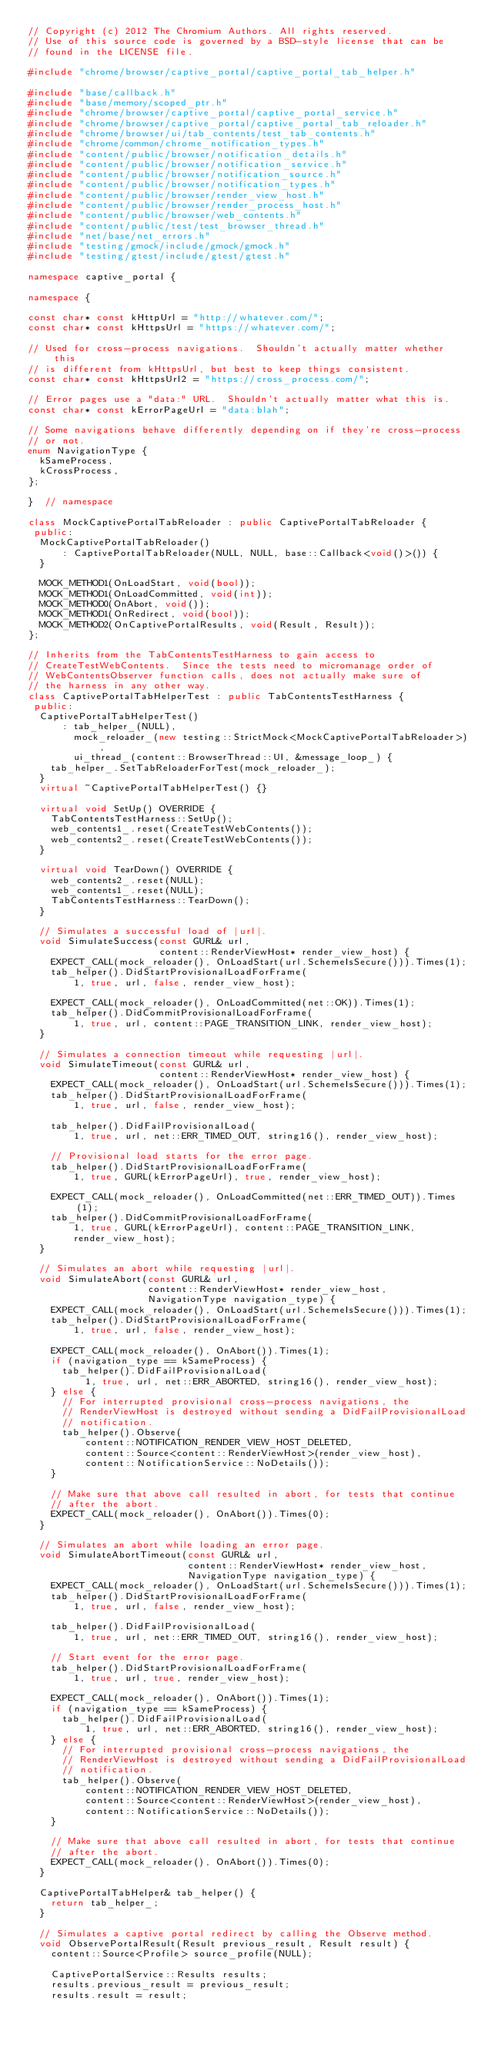<code> <loc_0><loc_0><loc_500><loc_500><_C++_>// Copyright (c) 2012 The Chromium Authors. All rights reserved.
// Use of this source code is governed by a BSD-style license that can be
// found in the LICENSE file.

#include "chrome/browser/captive_portal/captive_portal_tab_helper.h"

#include "base/callback.h"
#include "base/memory/scoped_ptr.h"
#include "chrome/browser/captive_portal/captive_portal_service.h"
#include "chrome/browser/captive_portal/captive_portal_tab_reloader.h"
#include "chrome/browser/ui/tab_contents/test_tab_contents.h"
#include "chrome/common/chrome_notification_types.h"
#include "content/public/browser/notification_details.h"
#include "content/public/browser/notification_service.h"
#include "content/public/browser/notification_source.h"
#include "content/public/browser/notification_types.h"
#include "content/public/browser/render_view_host.h"
#include "content/public/browser/render_process_host.h"
#include "content/public/browser/web_contents.h"
#include "content/public/test/test_browser_thread.h"
#include "net/base/net_errors.h"
#include "testing/gmock/include/gmock/gmock.h"
#include "testing/gtest/include/gtest/gtest.h"

namespace captive_portal {

namespace {

const char* const kHttpUrl = "http://whatever.com/";
const char* const kHttpsUrl = "https://whatever.com/";

// Used for cross-process navigations.  Shouldn't actually matter whether this
// is different from kHttpsUrl, but best to keep things consistent.
const char* const kHttpsUrl2 = "https://cross_process.com/";

// Error pages use a "data:" URL.  Shouldn't actually matter what this is.
const char* const kErrorPageUrl = "data:blah";

// Some navigations behave differently depending on if they're cross-process
// or not.
enum NavigationType {
  kSameProcess,
  kCrossProcess,
};

}  // namespace

class MockCaptivePortalTabReloader : public CaptivePortalTabReloader {
 public:
  MockCaptivePortalTabReloader()
      : CaptivePortalTabReloader(NULL, NULL, base::Callback<void()>()) {
  }

  MOCK_METHOD1(OnLoadStart, void(bool));
  MOCK_METHOD1(OnLoadCommitted, void(int));
  MOCK_METHOD0(OnAbort, void());
  MOCK_METHOD1(OnRedirect, void(bool));
  MOCK_METHOD2(OnCaptivePortalResults, void(Result, Result));
};

// Inherits from the TabContentsTestHarness to gain access to
// CreateTestWebContents.  Since the tests need to micromanage order of
// WebContentsObserver function calls, does not actually make sure of
// the harness in any other way.
class CaptivePortalTabHelperTest : public TabContentsTestHarness {
 public:
  CaptivePortalTabHelperTest()
      : tab_helper_(NULL),
        mock_reloader_(new testing::StrictMock<MockCaptivePortalTabReloader>),
        ui_thread_(content::BrowserThread::UI, &message_loop_) {
    tab_helper_.SetTabReloaderForTest(mock_reloader_);
  }
  virtual ~CaptivePortalTabHelperTest() {}

  virtual void SetUp() OVERRIDE {
    TabContentsTestHarness::SetUp();
    web_contents1_.reset(CreateTestWebContents());
    web_contents2_.reset(CreateTestWebContents());
  }

  virtual void TearDown() OVERRIDE {
    web_contents2_.reset(NULL);
    web_contents1_.reset(NULL);
    TabContentsTestHarness::TearDown();
  }

  // Simulates a successful load of |url|.
  void SimulateSuccess(const GURL& url,
                       content::RenderViewHost* render_view_host) {
    EXPECT_CALL(mock_reloader(), OnLoadStart(url.SchemeIsSecure())).Times(1);
    tab_helper().DidStartProvisionalLoadForFrame(
        1, true, url, false, render_view_host);

    EXPECT_CALL(mock_reloader(), OnLoadCommitted(net::OK)).Times(1);
    tab_helper().DidCommitProvisionalLoadForFrame(
        1, true, url, content::PAGE_TRANSITION_LINK, render_view_host);
  }

  // Simulates a connection timeout while requesting |url|.
  void SimulateTimeout(const GURL& url,
                       content::RenderViewHost* render_view_host) {
    EXPECT_CALL(mock_reloader(), OnLoadStart(url.SchemeIsSecure())).Times(1);
    tab_helper().DidStartProvisionalLoadForFrame(
        1, true, url, false, render_view_host);

    tab_helper().DidFailProvisionalLoad(
        1, true, url, net::ERR_TIMED_OUT, string16(), render_view_host);

    // Provisional load starts for the error page.
    tab_helper().DidStartProvisionalLoadForFrame(
        1, true, GURL(kErrorPageUrl), true, render_view_host);

    EXPECT_CALL(mock_reloader(), OnLoadCommitted(net::ERR_TIMED_OUT)).Times(1);
    tab_helper().DidCommitProvisionalLoadForFrame(
        1, true, GURL(kErrorPageUrl), content::PAGE_TRANSITION_LINK,
        render_view_host);
  }

  // Simulates an abort while requesting |url|.
  void SimulateAbort(const GURL& url,
                     content::RenderViewHost* render_view_host,
                     NavigationType navigation_type) {
    EXPECT_CALL(mock_reloader(), OnLoadStart(url.SchemeIsSecure())).Times(1);
    tab_helper().DidStartProvisionalLoadForFrame(
        1, true, url, false, render_view_host);

    EXPECT_CALL(mock_reloader(), OnAbort()).Times(1);
    if (navigation_type == kSameProcess) {
      tab_helper().DidFailProvisionalLoad(
          1, true, url, net::ERR_ABORTED, string16(), render_view_host);
    } else {
      // For interrupted provisional cross-process navigations, the
      // RenderViewHost is destroyed without sending a DidFailProvisionalLoad
      // notification.
      tab_helper().Observe(
          content::NOTIFICATION_RENDER_VIEW_HOST_DELETED,
          content::Source<content::RenderViewHost>(render_view_host),
          content::NotificationService::NoDetails());
    }

    // Make sure that above call resulted in abort, for tests that continue
    // after the abort.
    EXPECT_CALL(mock_reloader(), OnAbort()).Times(0);
  }

  // Simulates an abort while loading an error page.
  void SimulateAbortTimeout(const GURL& url,
                            content::RenderViewHost* render_view_host,
                            NavigationType navigation_type) {
    EXPECT_CALL(mock_reloader(), OnLoadStart(url.SchemeIsSecure())).Times(1);
    tab_helper().DidStartProvisionalLoadForFrame(
        1, true, url, false, render_view_host);

    tab_helper().DidFailProvisionalLoad(
        1, true, url, net::ERR_TIMED_OUT, string16(), render_view_host);

    // Start event for the error page.
    tab_helper().DidStartProvisionalLoadForFrame(
        1, true, url, true, render_view_host);

    EXPECT_CALL(mock_reloader(), OnAbort()).Times(1);
    if (navigation_type == kSameProcess) {
      tab_helper().DidFailProvisionalLoad(
          1, true, url, net::ERR_ABORTED, string16(), render_view_host);
    } else {
      // For interrupted provisional cross-process navigations, the
      // RenderViewHost is destroyed without sending a DidFailProvisionalLoad
      // notification.
      tab_helper().Observe(
          content::NOTIFICATION_RENDER_VIEW_HOST_DELETED,
          content::Source<content::RenderViewHost>(render_view_host),
          content::NotificationService::NoDetails());
    }

    // Make sure that above call resulted in abort, for tests that continue
    // after the abort.
    EXPECT_CALL(mock_reloader(), OnAbort()).Times(0);
  }

  CaptivePortalTabHelper& tab_helper() {
    return tab_helper_;
  }

  // Simulates a captive portal redirect by calling the Observe method.
  void ObservePortalResult(Result previous_result, Result result) {
    content::Source<Profile> source_profile(NULL);

    CaptivePortalService::Results results;
    results.previous_result = previous_result;
    results.result = result;</code> 